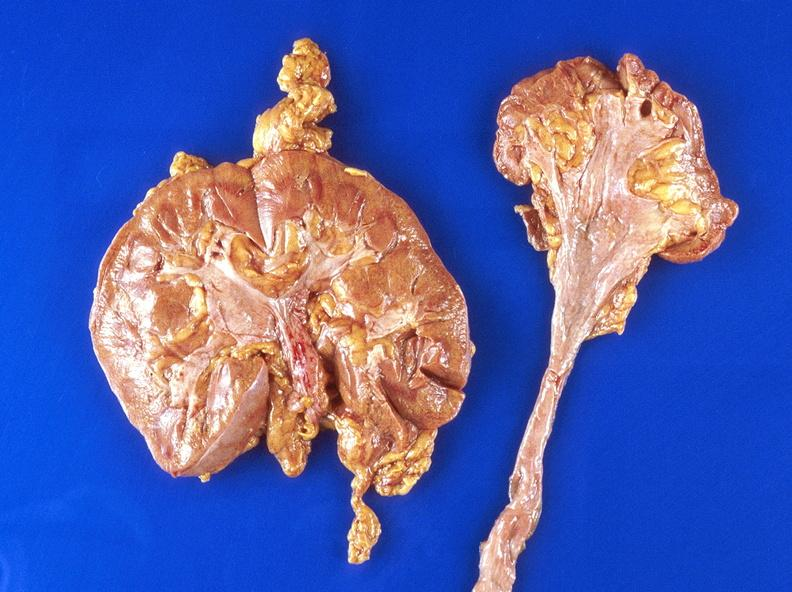where is this?
Answer the question using a single word or phrase. Urinary 